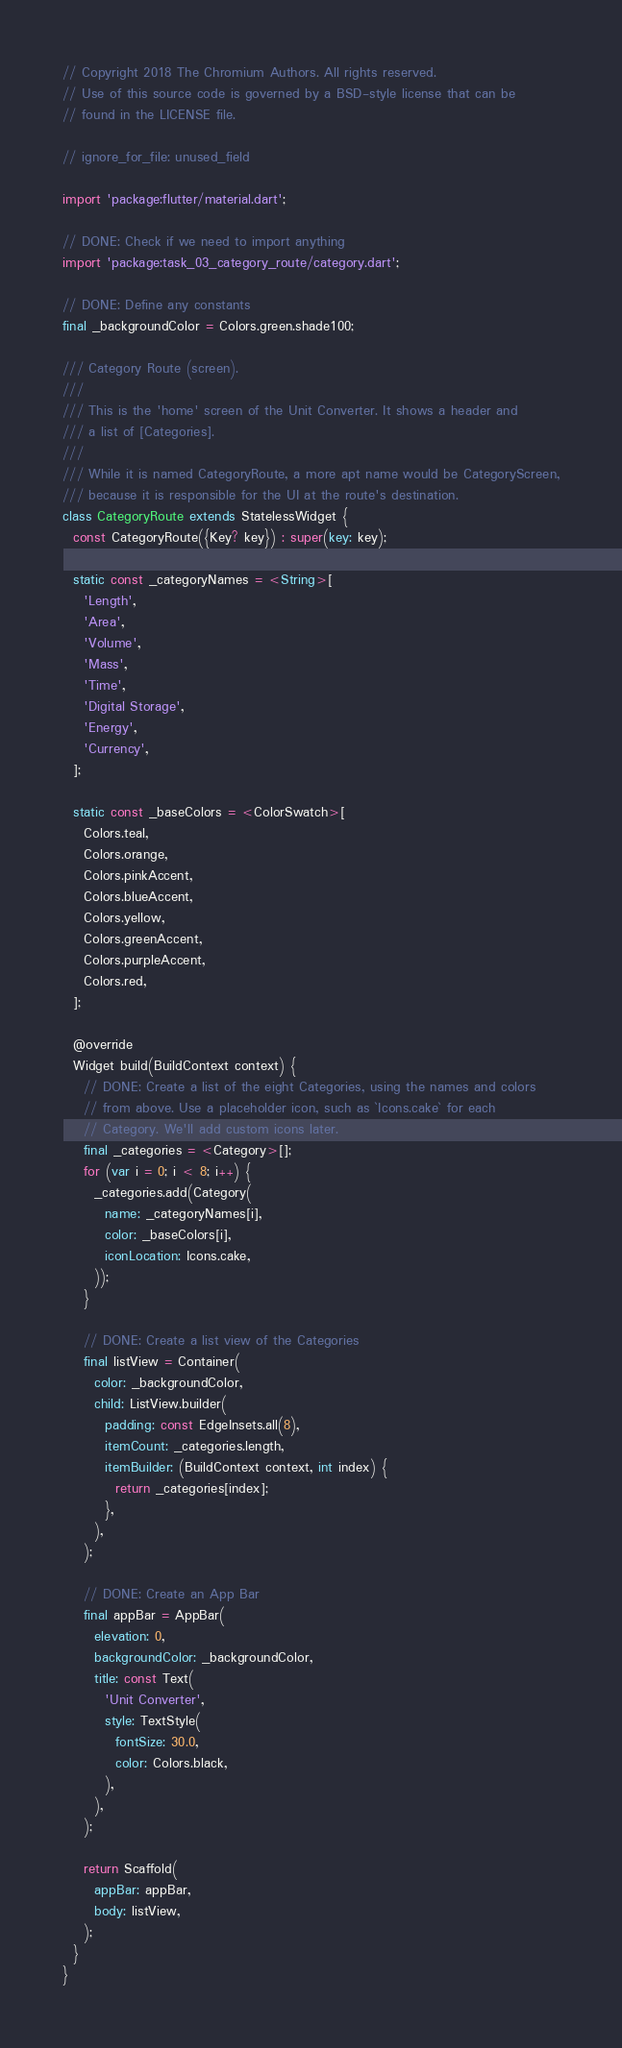Convert code to text. <code><loc_0><loc_0><loc_500><loc_500><_Dart_>// Copyright 2018 The Chromium Authors. All rights reserved.
// Use of this source code is governed by a BSD-style license that can be
// found in the LICENSE file.

// ignore_for_file: unused_field

import 'package:flutter/material.dart';

// DONE: Check if we need to import anything
import 'package:task_03_category_route/category.dart';

// DONE: Define any constants
final _backgroundColor = Colors.green.shade100;

/// Category Route (screen).
///
/// This is the 'home' screen of the Unit Converter. It shows a header and
/// a list of [Categories].
///
/// While it is named CategoryRoute, a more apt name would be CategoryScreen,
/// because it is responsible for the UI at the route's destination.
class CategoryRoute extends StatelessWidget {
  const CategoryRoute({Key? key}) : super(key: key);

  static const _categoryNames = <String>[
    'Length',
    'Area',
    'Volume',
    'Mass',
    'Time',
    'Digital Storage',
    'Energy',
    'Currency',
  ];

  static const _baseColors = <ColorSwatch>[
    Colors.teal,
    Colors.orange,
    Colors.pinkAccent,
    Colors.blueAccent,
    Colors.yellow,
    Colors.greenAccent,
    Colors.purpleAccent,
    Colors.red,
  ];

  @override
  Widget build(BuildContext context) {
    // DONE: Create a list of the eight Categories, using the names and colors
    // from above. Use a placeholder icon, such as `Icons.cake` for each
    // Category. We'll add custom icons later.
    final _categories = <Category>[];
    for (var i = 0; i < 8; i++) {
      _categories.add(Category(
        name: _categoryNames[i],
        color: _baseColors[i],
        iconLocation: Icons.cake,
      ));
    }

    // DONE: Create a list view of the Categories
    final listView = Container(
      color: _backgroundColor,
      child: ListView.builder(
        padding: const EdgeInsets.all(8),
        itemCount: _categories.length,
        itemBuilder: (BuildContext context, int index) {
          return _categories[index];
        },
      ),
    );

    // DONE: Create an App Bar
    final appBar = AppBar(
      elevation: 0,
      backgroundColor: _backgroundColor,
      title: const Text(
        'Unit Converter',
        style: TextStyle(
          fontSize: 30.0,
          color: Colors.black,
        ),
      ),
    );

    return Scaffold(
      appBar: appBar,
      body: listView,
    );
  }
}
</code> 